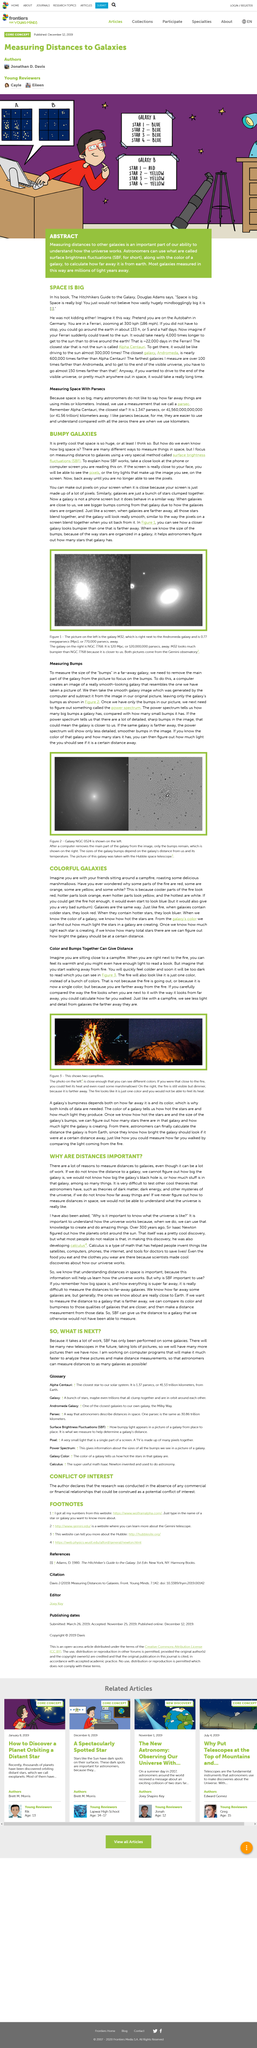Mention a couple of crucial points in this snapshot. The power spectrum provides insight into the number of large and small bumps a galaxy has compared to one another. Surface brightness fluctuations is a method used to determine the distance of galaxies by measuring variations in their brightness. This technique is commonly used to study the properties of galaxies and their environments. By knowing the temperature of the stars in a galaxy and the size of their galaxy bumps, we can calculate the distance of the galaxy from Earth. The image depicts the galaxy NGC 0524, which is positioned on the left-hand side. Combining color and bump information together can provide us with valuable distance information. 